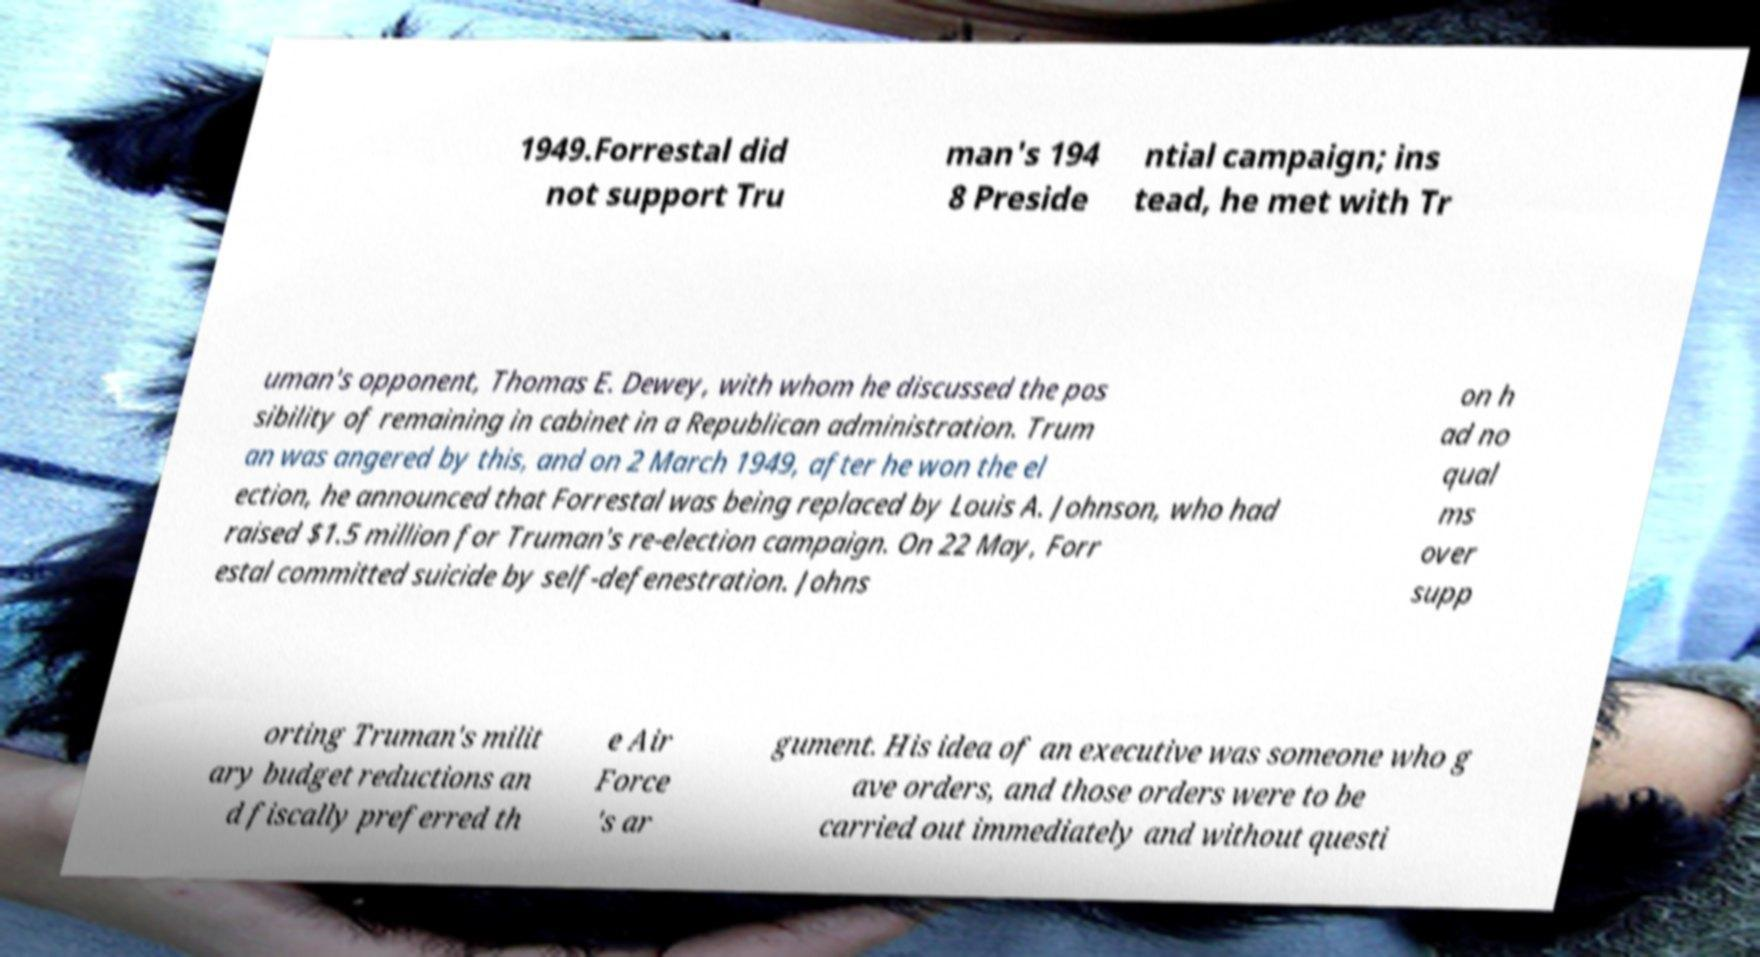What messages or text are displayed in this image? I need them in a readable, typed format. 1949.Forrestal did not support Tru man's 194 8 Preside ntial campaign; ins tead, he met with Tr uman's opponent, Thomas E. Dewey, with whom he discussed the pos sibility of remaining in cabinet in a Republican administration. Trum an was angered by this, and on 2 March 1949, after he won the el ection, he announced that Forrestal was being replaced by Louis A. Johnson, who had raised $1.5 million for Truman's re-election campaign. On 22 May, Forr estal committed suicide by self-defenestration. Johns on h ad no qual ms over supp orting Truman's milit ary budget reductions an d fiscally preferred th e Air Force 's ar gument. His idea of an executive was someone who g ave orders, and those orders were to be carried out immediately and without questi 